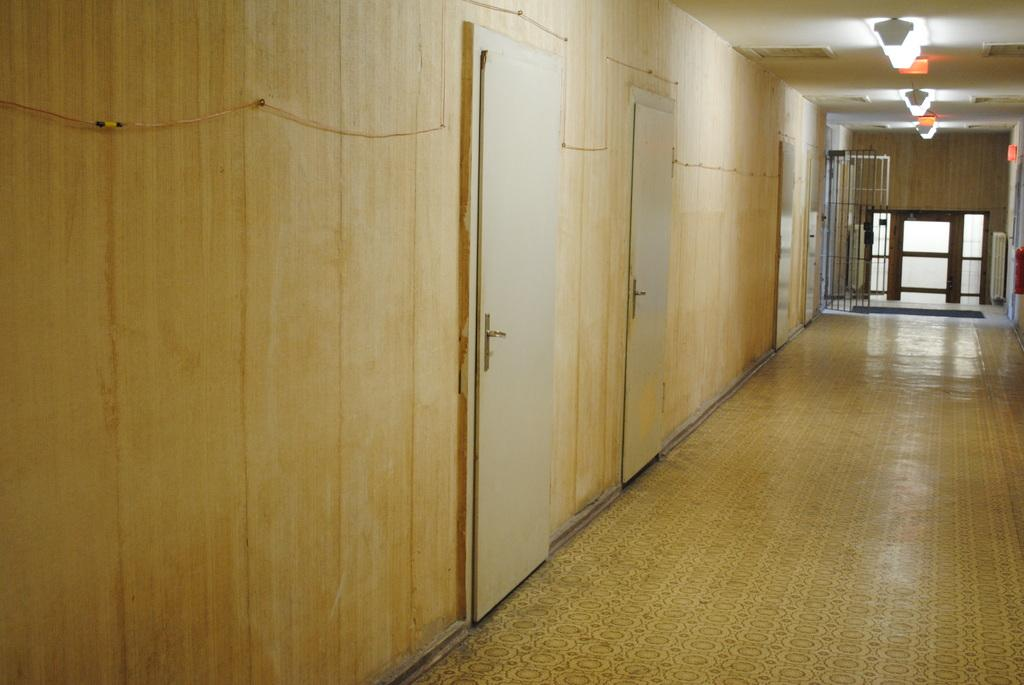What type of structure is shown in the image? The image is of a building. Where are the doors located on the building? The doors are on the left side of the building. What can be seen on the wall of the building? There is a wire on the wall. What is at the top of the building? There are lights at the top of the building. What is at the bottom of the building? There is a mat at the bottom of the building. What word is written on the sign in front of the building? There is no sign present in the image, so no word can be read. How many geese are standing on the mat at the bottom of the building? There are no geese present in the image; only a mat is visible at the bottom of the building. 